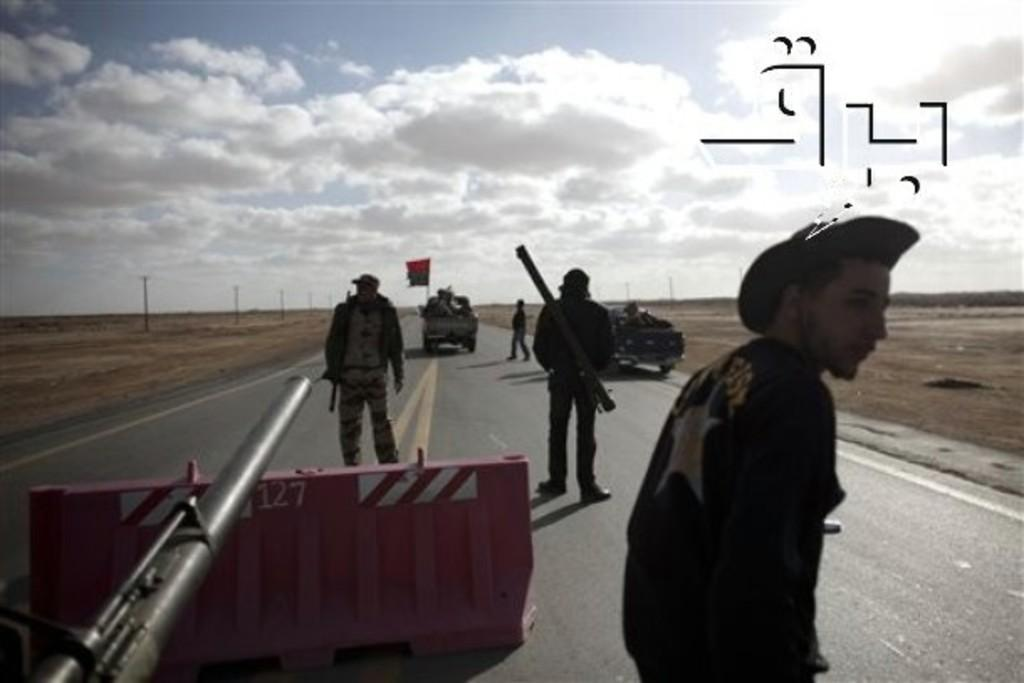What are the people in the image doing? The people in the image are standing on the road. What else can be seen on the road in the image? There are vehicles visible in the image. What objects are present along the road in the image? There are poles in the image. What is visible in the sky in the image? There are clouds in the sky, and the sky is visible at the top of the image. What holiday is being celebrated in the image? There is no indication of a holiday being celebrated in the image. What shape is the square in the image? There is no square present in the image. 